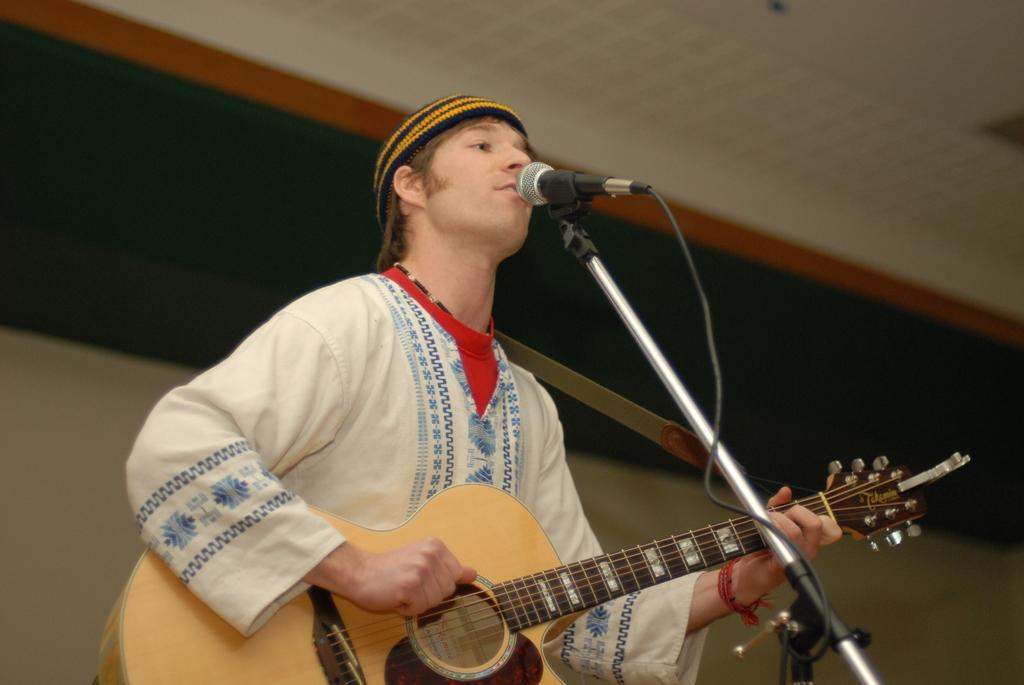How would you summarize this image in a sentence or two? This person holding guitar and singing. There is a microphone with stand. 